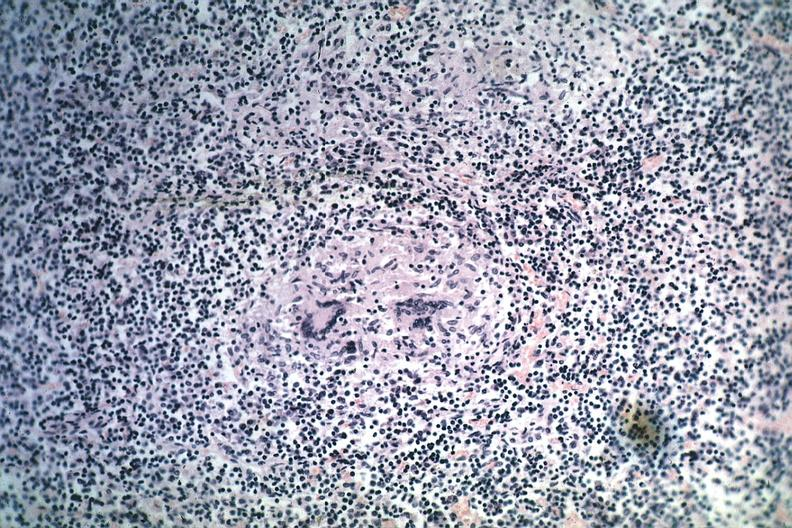s lymph node present?
Answer the question using a single word or phrase. Yes 